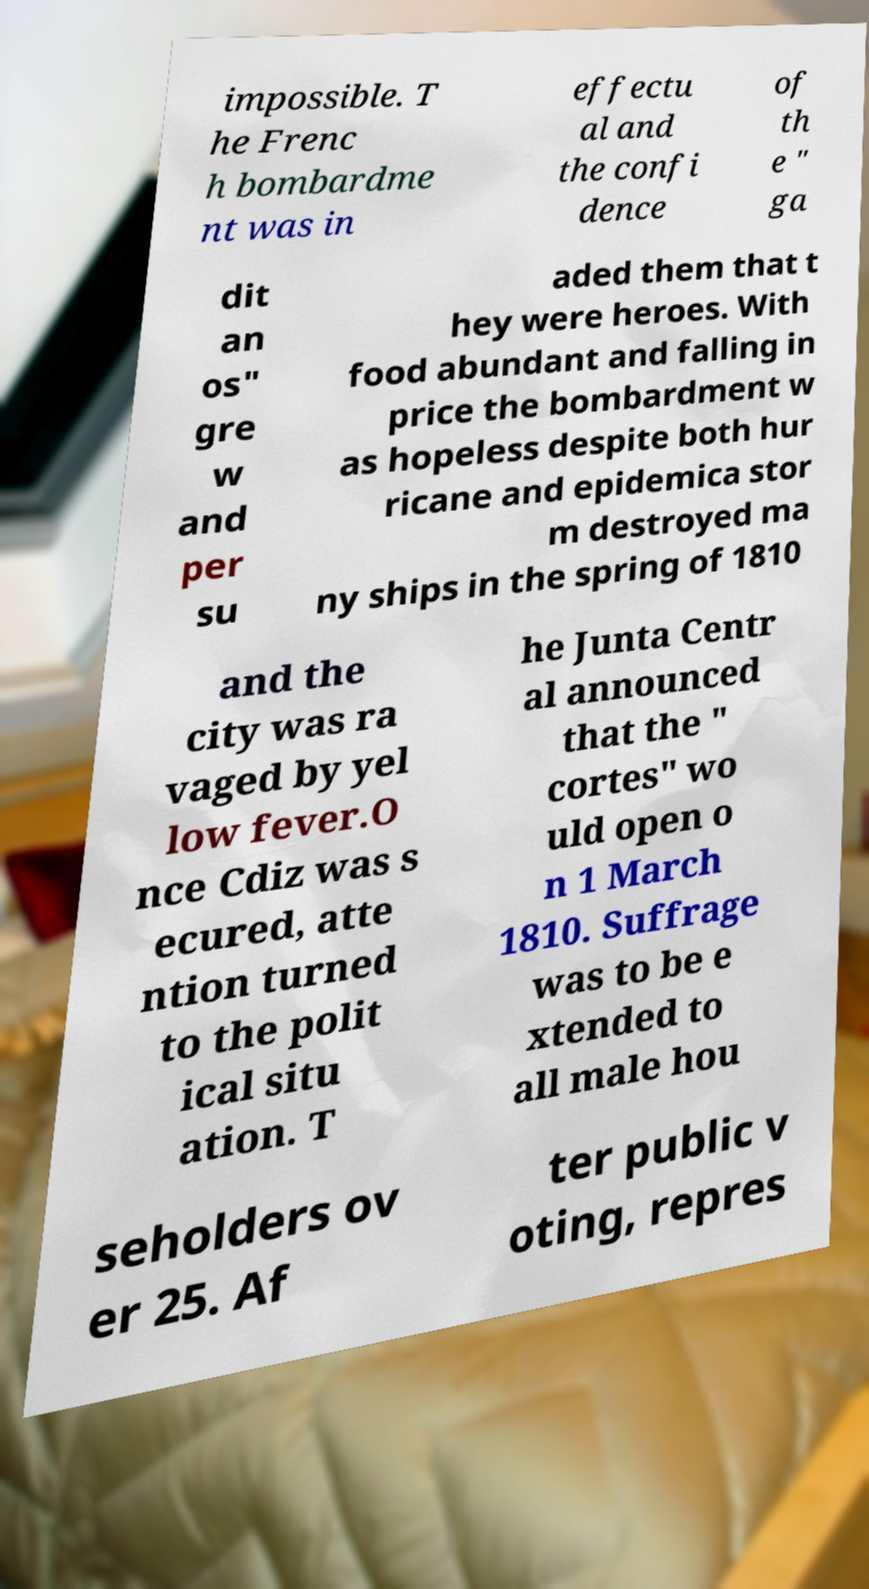There's text embedded in this image that I need extracted. Can you transcribe it verbatim? impossible. T he Frenc h bombardme nt was in effectu al and the confi dence of th e " ga dit an os" gre w and per su aded them that t hey were heroes. With food abundant and falling in price the bombardment w as hopeless despite both hur ricane and epidemica stor m destroyed ma ny ships in the spring of 1810 and the city was ra vaged by yel low fever.O nce Cdiz was s ecured, atte ntion turned to the polit ical situ ation. T he Junta Centr al announced that the " cortes" wo uld open o n 1 March 1810. Suffrage was to be e xtended to all male hou seholders ov er 25. Af ter public v oting, repres 